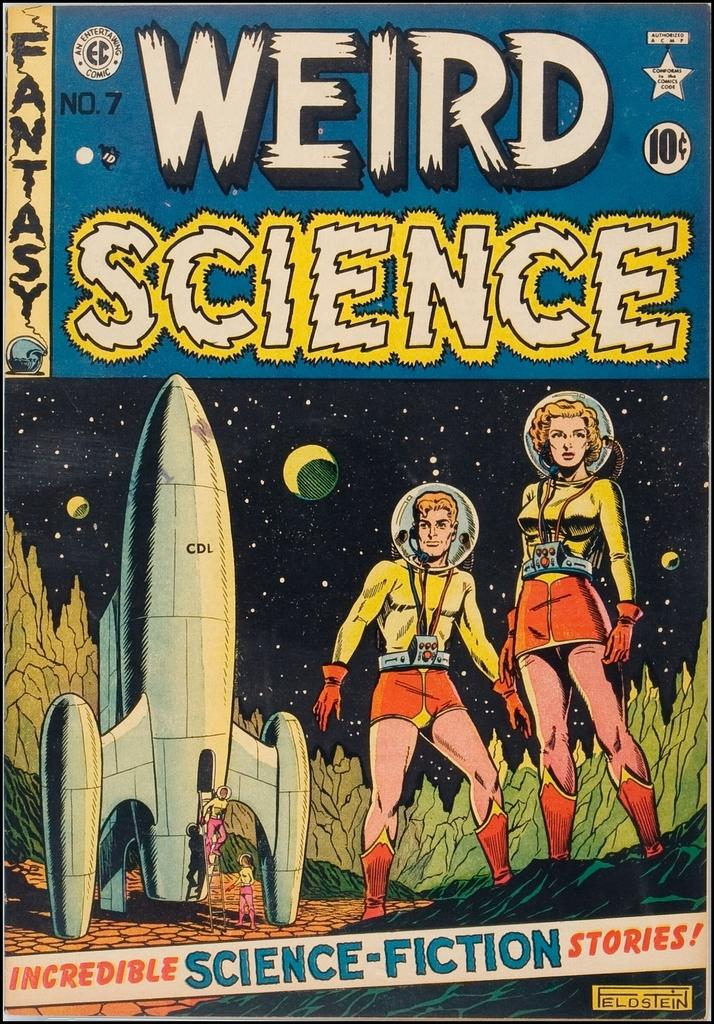<image>
Share a concise interpretation of the image provided. A weird science comic book costs 10 cents 